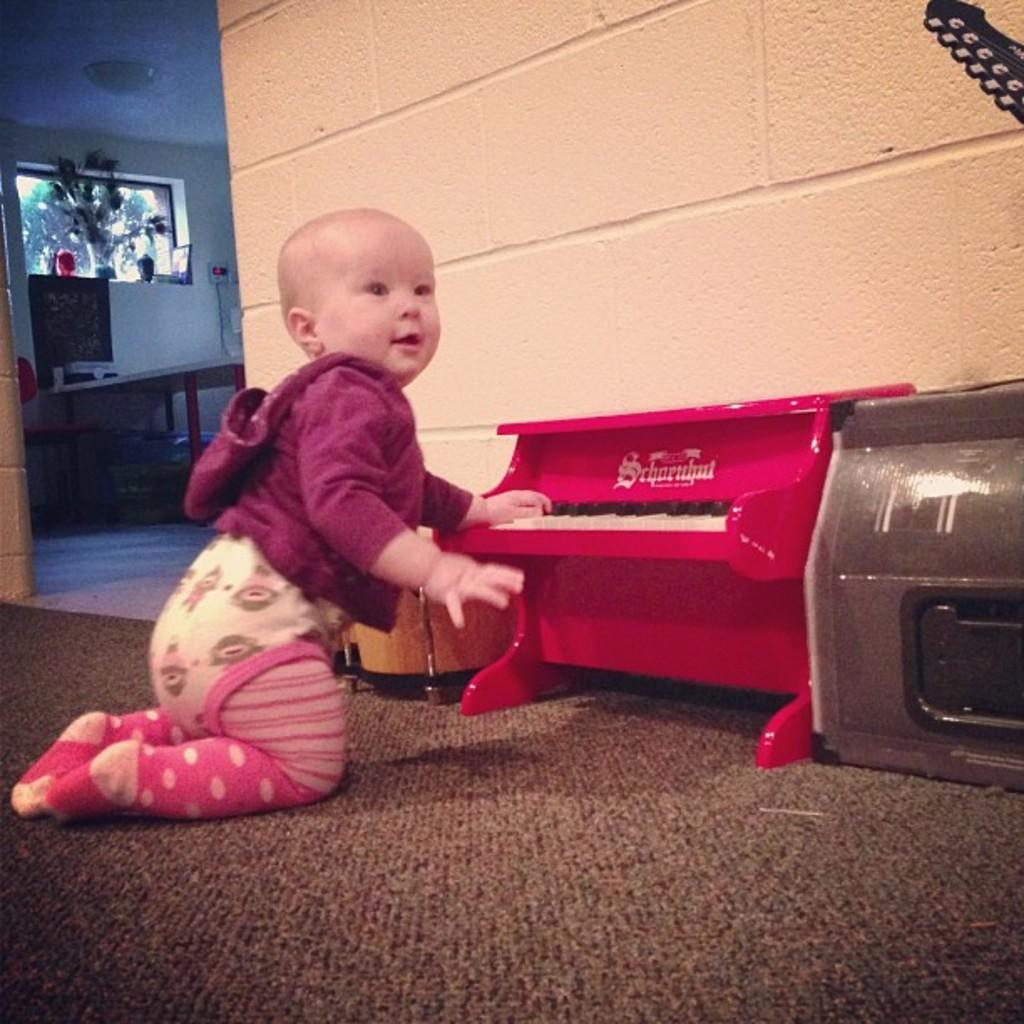What is on the floor in the image? There is a baby on the floor. What structure can be seen in the image? There is a table in the image. What is the background of the image made up of? There is a wall in the image. What type of glove is the baby wearing in the picture? There is no glove visible on the baby in the image. How many coils can be seen on the wall in the image? There are no coils present on the wall in the image. 